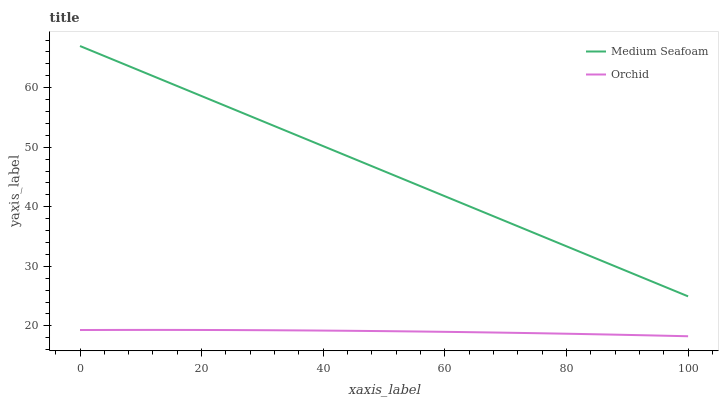Does Orchid have the maximum area under the curve?
Answer yes or no. No. Is Orchid the smoothest?
Answer yes or no. No. Does Orchid have the highest value?
Answer yes or no. No. Is Orchid less than Medium Seafoam?
Answer yes or no. Yes. Is Medium Seafoam greater than Orchid?
Answer yes or no. Yes. Does Orchid intersect Medium Seafoam?
Answer yes or no. No. 